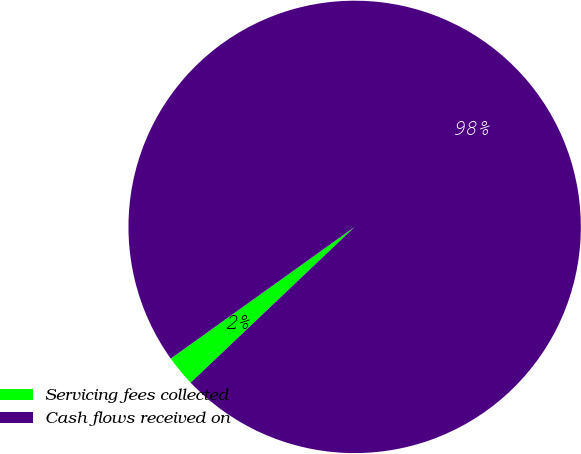Convert chart. <chart><loc_0><loc_0><loc_500><loc_500><pie_chart><fcel>Servicing fees collected<fcel>Cash flows received on<nl><fcel>2.2%<fcel>97.8%<nl></chart> 